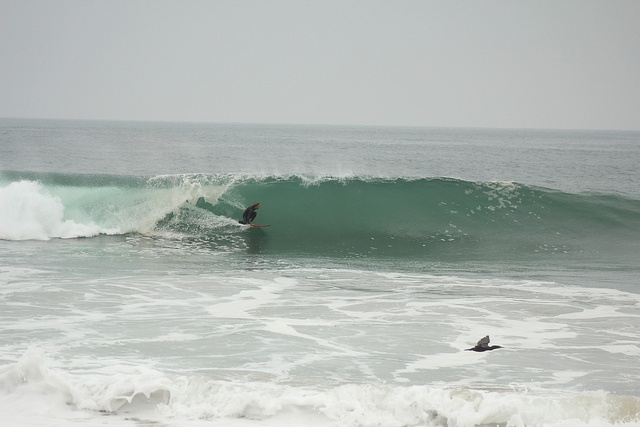Describe the objects in this image and their specific colors. I can see people in darkgray, black, gray, and maroon tones, bird in darkgray, gray, black, and lightgray tones, and surfboard in darkgray, gray, maroon, and teal tones in this image. 